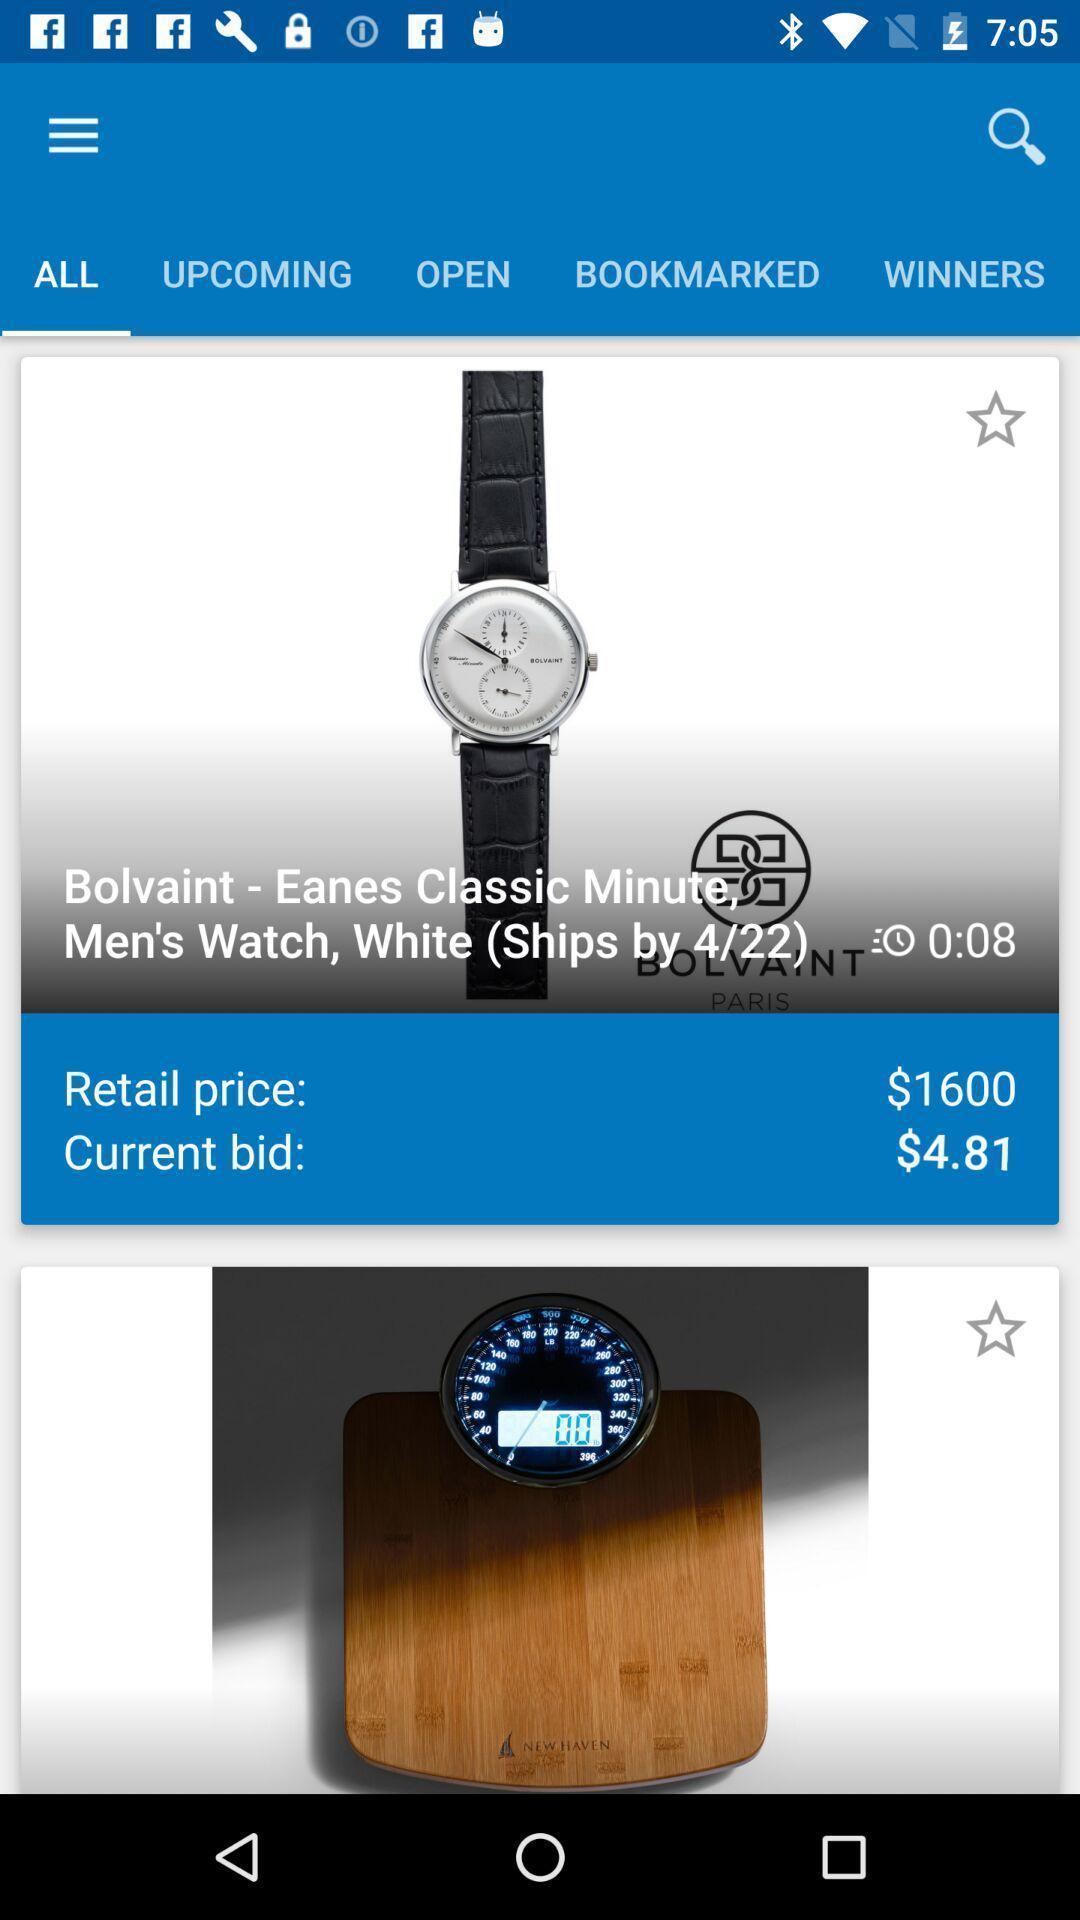Describe the visual elements of this screenshot. Screen displaying of shopping application. 